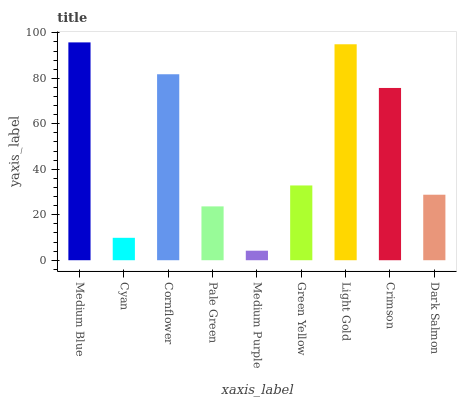Is Medium Purple the minimum?
Answer yes or no. Yes. Is Medium Blue the maximum?
Answer yes or no. Yes. Is Cyan the minimum?
Answer yes or no. No. Is Cyan the maximum?
Answer yes or no. No. Is Medium Blue greater than Cyan?
Answer yes or no. Yes. Is Cyan less than Medium Blue?
Answer yes or no. Yes. Is Cyan greater than Medium Blue?
Answer yes or no. No. Is Medium Blue less than Cyan?
Answer yes or no. No. Is Green Yellow the high median?
Answer yes or no. Yes. Is Green Yellow the low median?
Answer yes or no. Yes. Is Pale Green the high median?
Answer yes or no. No. Is Medium Purple the low median?
Answer yes or no. No. 